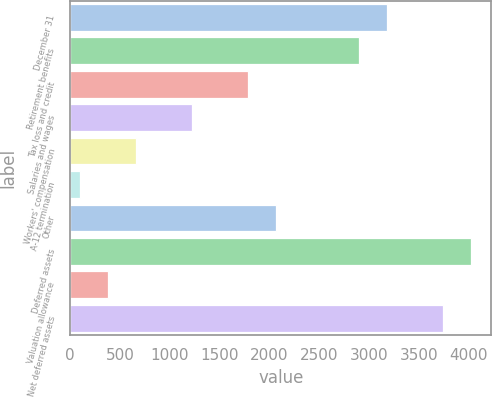<chart> <loc_0><loc_0><loc_500><loc_500><bar_chart><fcel>December 31<fcel>Retirement benefits<fcel>Tax loss and credit<fcel>Salaries and wages<fcel>Workers' compensation<fcel>A-12 termination<fcel>Other<fcel>Deferred assets<fcel>Valuation allowance<fcel>Net deferred assets<nl><fcel>3184.9<fcel>2904<fcel>1780.4<fcel>1218.6<fcel>656.8<fcel>95<fcel>2061.3<fcel>4027.6<fcel>375.9<fcel>3746.7<nl></chart> 